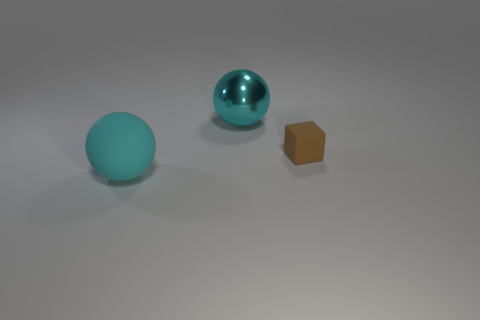Add 2 big cyan rubber spheres. How many objects exist? 5 Subtract all balls. How many objects are left? 1 Subtract all blue metal cubes. Subtract all brown rubber blocks. How many objects are left? 2 Add 3 large cyan metal things. How many large cyan metal things are left? 4 Add 1 tiny brown things. How many tiny brown things exist? 2 Subtract 0 purple cubes. How many objects are left? 3 